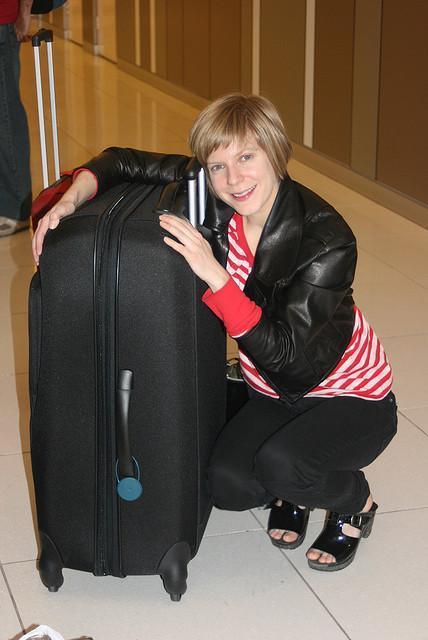How many suitcases do you see?
Give a very brief answer. 1. How many people are there?
Give a very brief answer. 2. 